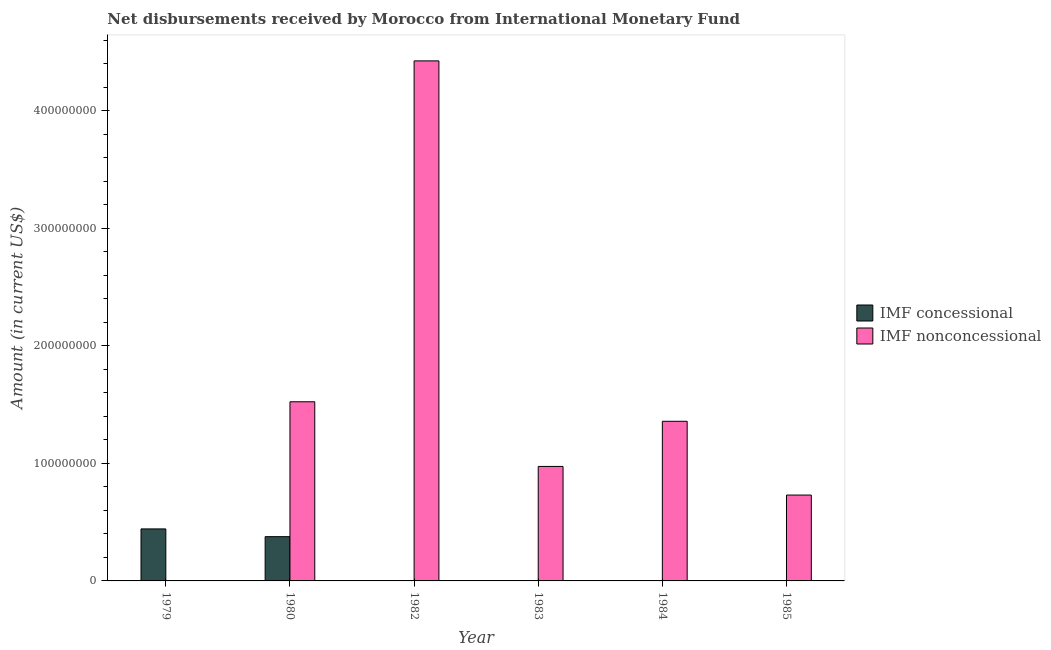Are the number of bars on each tick of the X-axis equal?
Offer a terse response. No. How many bars are there on the 2nd tick from the right?
Keep it short and to the point. 1. In how many cases, is the number of bars for a given year not equal to the number of legend labels?
Provide a succinct answer. 5. What is the net concessional disbursements from imf in 1980?
Provide a short and direct response. 3.77e+07. Across all years, what is the maximum net concessional disbursements from imf?
Your answer should be very brief. 4.42e+07. In which year was the net concessional disbursements from imf maximum?
Your answer should be compact. 1979. What is the total net non concessional disbursements from imf in the graph?
Your response must be concise. 9.01e+08. What is the difference between the net concessional disbursements from imf in 1979 and that in 1980?
Keep it short and to the point. 6.59e+06. What is the difference between the net non concessional disbursements from imf in 1979 and the net concessional disbursements from imf in 1982?
Your answer should be compact. -4.42e+08. What is the average net concessional disbursements from imf per year?
Your response must be concise. 1.36e+07. In how many years, is the net concessional disbursements from imf greater than 120000000 US$?
Provide a succinct answer. 0. What is the ratio of the net non concessional disbursements from imf in 1982 to that in 1983?
Keep it short and to the point. 4.54. Is the net non concessional disbursements from imf in 1980 less than that in 1983?
Give a very brief answer. No. What is the difference between the highest and the second highest net non concessional disbursements from imf?
Your answer should be very brief. 2.90e+08. What is the difference between the highest and the lowest net non concessional disbursements from imf?
Your answer should be compact. 4.42e+08. How many bars are there?
Offer a terse response. 7. Are all the bars in the graph horizontal?
Ensure brevity in your answer.  No. What is the difference between two consecutive major ticks on the Y-axis?
Offer a very short reply. 1.00e+08. Are the values on the major ticks of Y-axis written in scientific E-notation?
Provide a short and direct response. No. Does the graph contain any zero values?
Provide a short and direct response. Yes. How many legend labels are there?
Make the answer very short. 2. What is the title of the graph?
Keep it short and to the point. Net disbursements received by Morocco from International Monetary Fund. Does "Measles" appear as one of the legend labels in the graph?
Provide a short and direct response. No. What is the label or title of the Y-axis?
Make the answer very short. Amount (in current US$). What is the Amount (in current US$) in IMF concessional in 1979?
Provide a succinct answer. 4.42e+07. What is the Amount (in current US$) in IMF nonconcessional in 1979?
Give a very brief answer. 0. What is the Amount (in current US$) of IMF concessional in 1980?
Make the answer very short. 3.77e+07. What is the Amount (in current US$) of IMF nonconcessional in 1980?
Your answer should be compact. 1.52e+08. What is the Amount (in current US$) in IMF concessional in 1982?
Your answer should be very brief. 0. What is the Amount (in current US$) in IMF nonconcessional in 1982?
Provide a short and direct response. 4.42e+08. What is the Amount (in current US$) in IMF nonconcessional in 1983?
Give a very brief answer. 9.74e+07. What is the Amount (in current US$) in IMF concessional in 1984?
Your response must be concise. 0. What is the Amount (in current US$) of IMF nonconcessional in 1984?
Keep it short and to the point. 1.36e+08. What is the Amount (in current US$) of IMF nonconcessional in 1985?
Your response must be concise. 7.30e+07. Across all years, what is the maximum Amount (in current US$) in IMF concessional?
Offer a terse response. 4.42e+07. Across all years, what is the maximum Amount (in current US$) of IMF nonconcessional?
Ensure brevity in your answer.  4.42e+08. Across all years, what is the minimum Amount (in current US$) of IMF concessional?
Offer a very short reply. 0. What is the total Amount (in current US$) in IMF concessional in the graph?
Provide a short and direct response. 8.19e+07. What is the total Amount (in current US$) in IMF nonconcessional in the graph?
Your response must be concise. 9.01e+08. What is the difference between the Amount (in current US$) in IMF concessional in 1979 and that in 1980?
Give a very brief answer. 6.59e+06. What is the difference between the Amount (in current US$) of IMF nonconcessional in 1980 and that in 1982?
Make the answer very short. -2.90e+08. What is the difference between the Amount (in current US$) of IMF nonconcessional in 1980 and that in 1983?
Provide a short and direct response. 5.50e+07. What is the difference between the Amount (in current US$) of IMF nonconcessional in 1980 and that in 1984?
Provide a succinct answer. 1.66e+07. What is the difference between the Amount (in current US$) of IMF nonconcessional in 1980 and that in 1985?
Your response must be concise. 7.94e+07. What is the difference between the Amount (in current US$) of IMF nonconcessional in 1982 and that in 1983?
Your answer should be very brief. 3.45e+08. What is the difference between the Amount (in current US$) of IMF nonconcessional in 1982 and that in 1984?
Offer a very short reply. 3.07e+08. What is the difference between the Amount (in current US$) of IMF nonconcessional in 1982 and that in 1985?
Offer a terse response. 3.69e+08. What is the difference between the Amount (in current US$) of IMF nonconcessional in 1983 and that in 1984?
Your response must be concise. -3.84e+07. What is the difference between the Amount (in current US$) of IMF nonconcessional in 1983 and that in 1985?
Keep it short and to the point. 2.44e+07. What is the difference between the Amount (in current US$) in IMF nonconcessional in 1984 and that in 1985?
Your response must be concise. 6.28e+07. What is the difference between the Amount (in current US$) in IMF concessional in 1979 and the Amount (in current US$) in IMF nonconcessional in 1980?
Ensure brevity in your answer.  -1.08e+08. What is the difference between the Amount (in current US$) of IMF concessional in 1979 and the Amount (in current US$) of IMF nonconcessional in 1982?
Keep it short and to the point. -3.98e+08. What is the difference between the Amount (in current US$) of IMF concessional in 1979 and the Amount (in current US$) of IMF nonconcessional in 1983?
Your answer should be very brief. -5.32e+07. What is the difference between the Amount (in current US$) in IMF concessional in 1979 and the Amount (in current US$) in IMF nonconcessional in 1984?
Offer a very short reply. -9.16e+07. What is the difference between the Amount (in current US$) in IMF concessional in 1979 and the Amount (in current US$) in IMF nonconcessional in 1985?
Provide a short and direct response. -2.88e+07. What is the difference between the Amount (in current US$) in IMF concessional in 1980 and the Amount (in current US$) in IMF nonconcessional in 1982?
Your response must be concise. -4.05e+08. What is the difference between the Amount (in current US$) in IMF concessional in 1980 and the Amount (in current US$) in IMF nonconcessional in 1983?
Your answer should be very brief. -5.97e+07. What is the difference between the Amount (in current US$) in IMF concessional in 1980 and the Amount (in current US$) in IMF nonconcessional in 1984?
Ensure brevity in your answer.  -9.81e+07. What is the difference between the Amount (in current US$) of IMF concessional in 1980 and the Amount (in current US$) of IMF nonconcessional in 1985?
Your response must be concise. -3.54e+07. What is the average Amount (in current US$) in IMF concessional per year?
Your answer should be compact. 1.36e+07. What is the average Amount (in current US$) in IMF nonconcessional per year?
Provide a succinct answer. 1.50e+08. In the year 1980, what is the difference between the Amount (in current US$) in IMF concessional and Amount (in current US$) in IMF nonconcessional?
Make the answer very short. -1.15e+08. What is the ratio of the Amount (in current US$) of IMF concessional in 1979 to that in 1980?
Provide a succinct answer. 1.17. What is the ratio of the Amount (in current US$) of IMF nonconcessional in 1980 to that in 1982?
Make the answer very short. 0.34. What is the ratio of the Amount (in current US$) of IMF nonconcessional in 1980 to that in 1983?
Ensure brevity in your answer.  1.56. What is the ratio of the Amount (in current US$) of IMF nonconcessional in 1980 to that in 1984?
Provide a short and direct response. 1.12. What is the ratio of the Amount (in current US$) of IMF nonconcessional in 1980 to that in 1985?
Give a very brief answer. 2.09. What is the ratio of the Amount (in current US$) of IMF nonconcessional in 1982 to that in 1983?
Provide a succinct answer. 4.54. What is the ratio of the Amount (in current US$) in IMF nonconcessional in 1982 to that in 1984?
Give a very brief answer. 3.26. What is the ratio of the Amount (in current US$) of IMF nonconcessional in 1982 to that in 1985?
Keep it short and to the point. 6.06. What is the ratio of the Amount (in current US$) in IMF nonconcessional in 1983 to that in 1984?
Make the answer very short. 0.72. What is the ratio of the Amount (in current US$) of IMF nonconcessional in 1983 to that in 1985?
Offer a very short reply. 1.33. What is the ratio of the Amount (in current US$) in IMF nonconcessional in 1984 to that in 1985?
Offer a terse response. 1.86. What is the difference between the highest and the second highest Amount (in current US$) of IMF nonconcessional?
Keep it short and to the point. 2.90e+08. What is the difference between the highest and the lowest Amount (in current US$) in IMF concessional?
Your response must be concise. 4.42e+07. What is the difference between the highest and the lowest Amount (in current US$) in IMF nonconcessional?
Provide a succinct answer. 4.42e+08. 